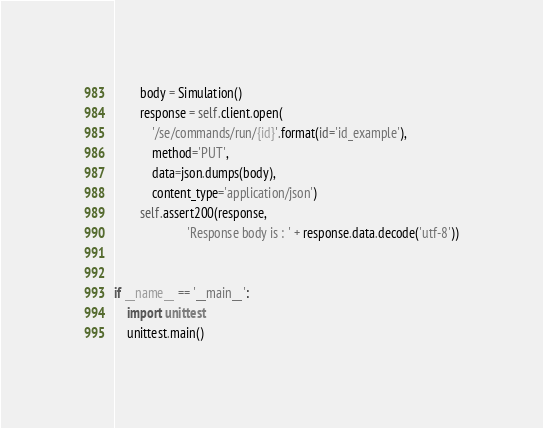Convert code to text. <code><loc_0><loc_0><loc_500><loc_500><_Python_>        body = Simulation()
        response = self.client.open(
            '/se/commands/run/{id}'.format(id='id_example'),
            method='PUT',
            data=json.dumps(body),
            content_type='application/json')
        self.assert200(response,
                       'Response body is : ' + response.data.decode('utf-8'))


if __name__ == '__main__':
    import unittest
    unittest.main()
</code> 